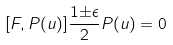<formula> <loc_0><loc_0><loc_500><loc_500>[ F , P ( u ) ] \frac { 1 { \pm } { \epsilon } } { 2 } P ( u ) = 0</formula> 